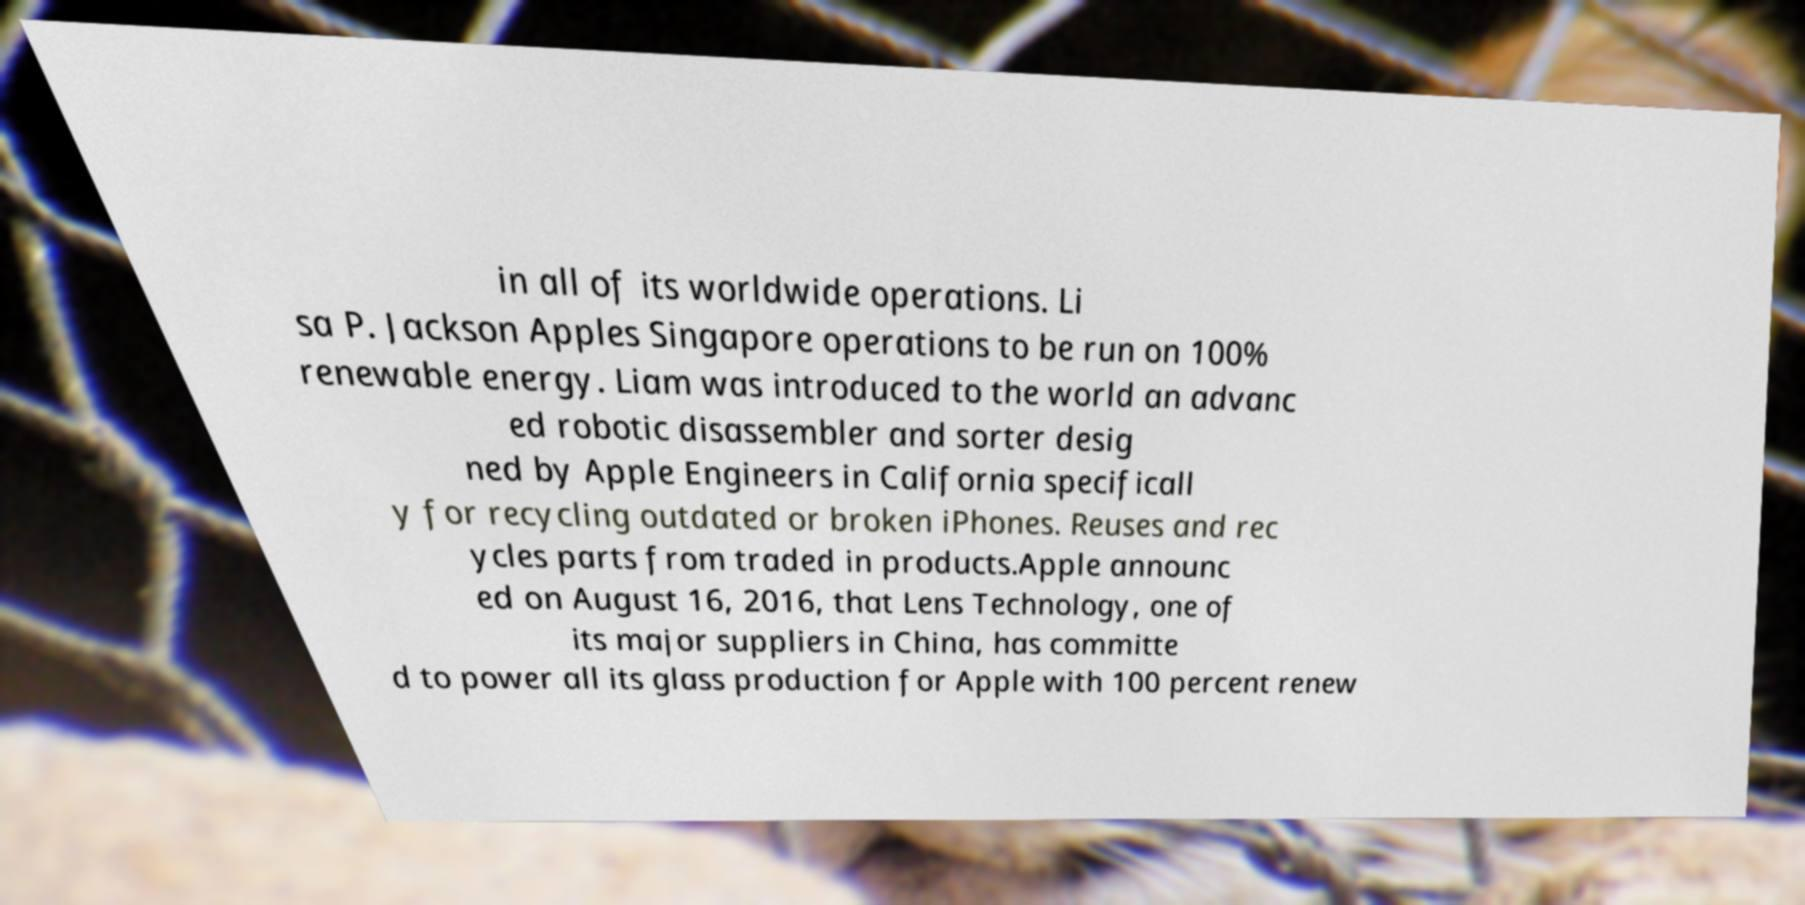Please identify and transcribe the text found in this image. in all of its worldwide operations. Li sa P. Jackson Apples Singapore operations to be run on 100% renewable energy. Liam was introduced to the world an advanc ed robotic disassembler and sorter desig ned by Apple Engineers in California specificall y for recycling outdated or broken iPhones. Reuses and rec ycles parts from traded in products.Apple announc ed on August 16, 2016, that Lens Technology, one of its major suppliers in China, has committe d to power all its glass production for Apple with 100 percent renew 